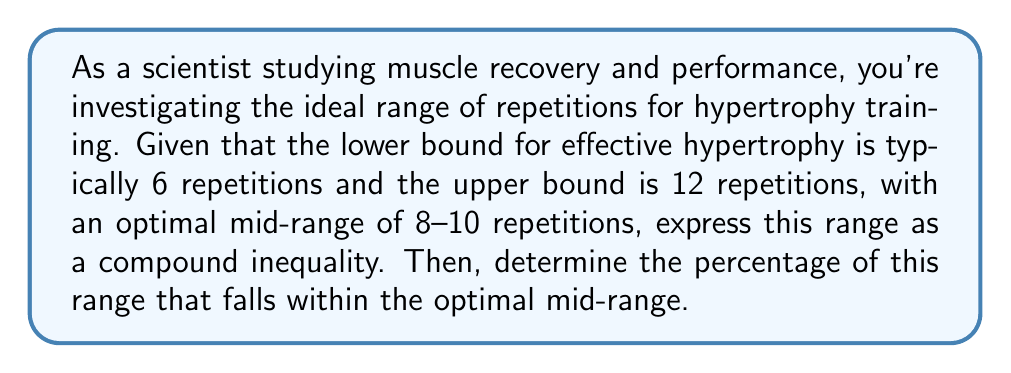What is the answer to this math problem? 1) First, let's express the full range as a compound inequality:
   $$ 6 \leq x \leq 12 $$
   where $x$ represents the number of repetitions.

2) The optimal mid-range is 8-10 repetitions, which we can express as:
   $$ 8 \leq x \leq 10 $$

3) To calculate the percentage of the full range that falls within the optimal mid-range:
   a) Calculate the total range: $12 - 6 = 6$ repetitions
   b) Calculate the optimal mid-range: $10 - 8 = 2$ repetitions

4) Calculate the percentage:
   $$ \text{Percentage} = \frac{\text{Optimal mid-range}}{\text{Total range}} \times 100\% $$
   $$ = \frac{2}{6} \times 100\% = \frac{1}{3} \times 100\% \approx 33.33\% $$

Therefore, approximately 33.33% of the full hypertrophy range falls within the optimal mid-range for repetitions.
Answer: $33.33\%$ 